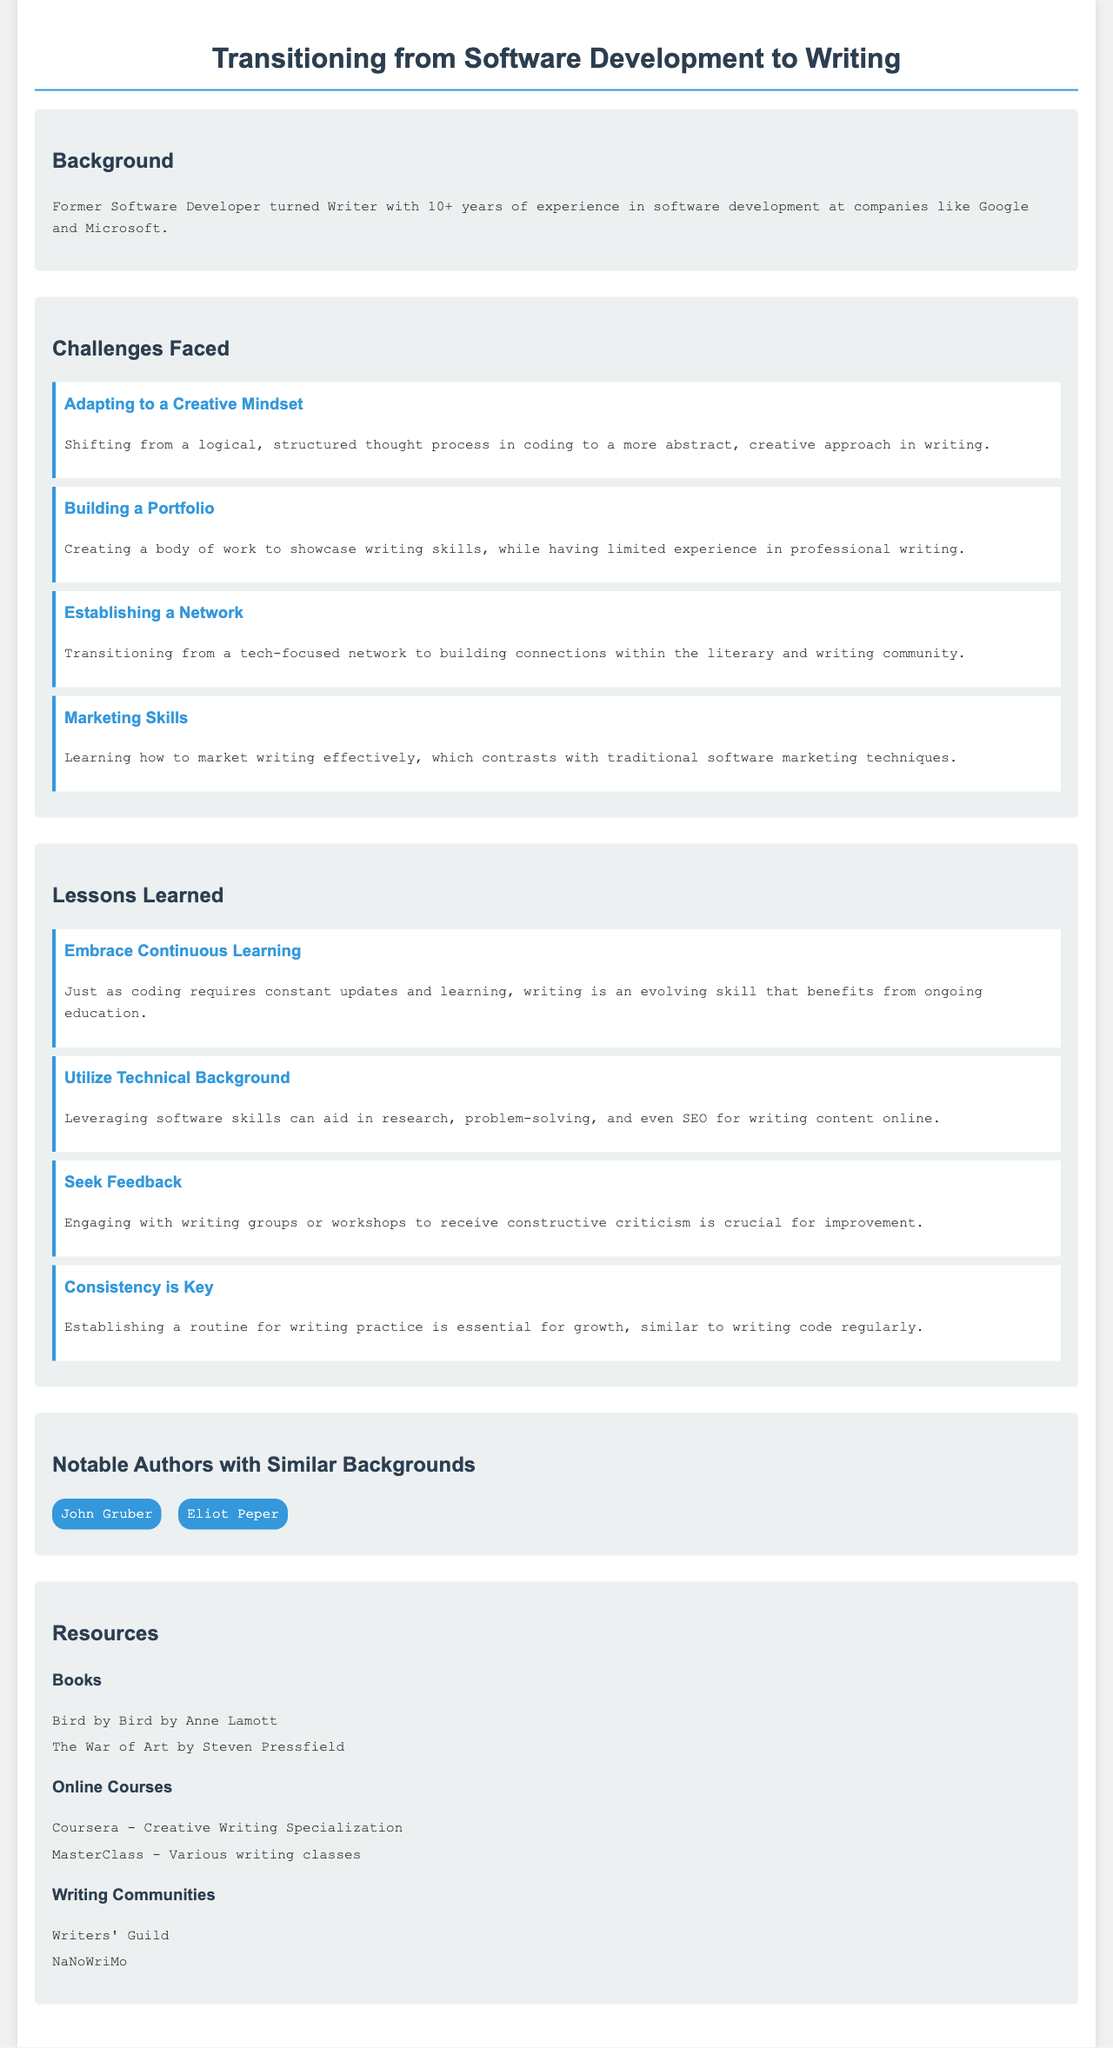What is the background of the author? The document states that the author is a "Former Software Developer turned Writer with 10+ years of experience".
Answer: Former Software Developer turned Writer How many challenges are mentioned in the document? The document lists four specific challenges faced during the transition.
Answer: 4 Name one notable author with a similar background. The document mentions authors who have transitioned from tech to writing, providing two examples.
Answer: John Gruber What lesson emphasizes the importance of receiving critiques? The document identifies a specific lesson related to feedback from writing groups or workshops.
Answer: Seek Feedback Which book is recommended in the resources section? The document includes a list of recommended books, one of which can be identified by title.
Answer: Bird by Bird by Anne Lamott What major skill does the lesson "Utilize Technical Background" highlight? The document outlines how leveraging software skills can be beneficial for writing.
Answer: Research What is the key to improvement according to one of the lessons learned? The lessons section indicates a specific approach that emphasizes regular practice.
Answer: Consistency is Key 